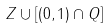<formula> <loc_0><loc_0><loc_500><loc_500>Z \cup [ ( 0 , 1 ) \cap Q ]</formula> 